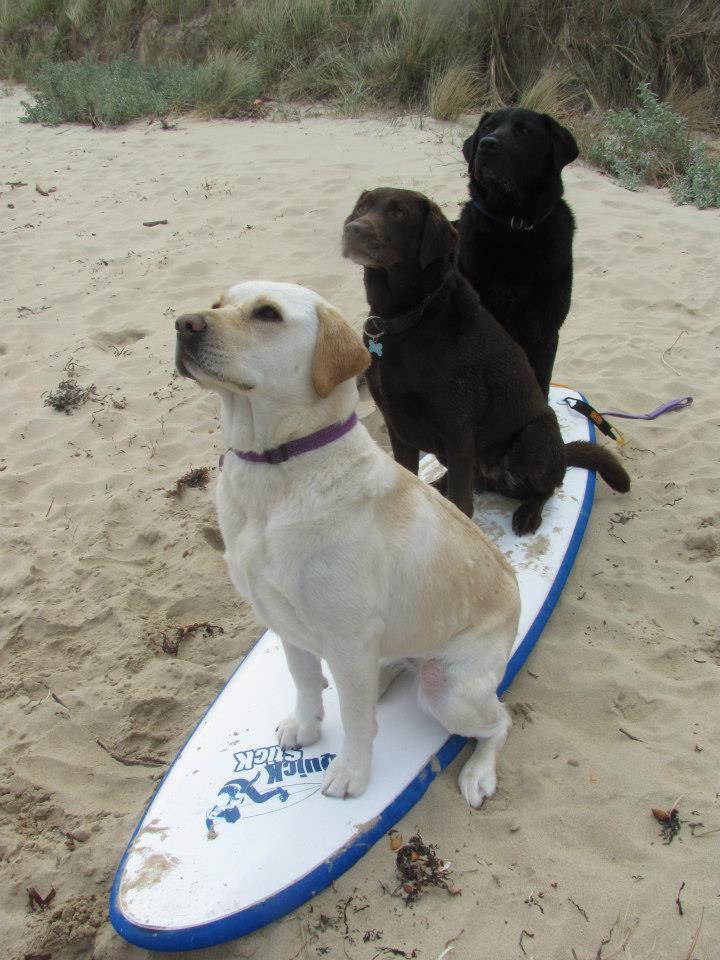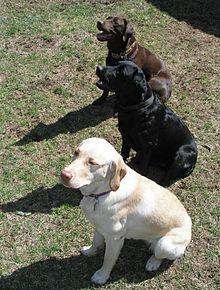The first image is the image on the left, the second image is the image on the right. For the images shown, is this caption "There is only one dog that is definitely in a sitting position." true? Answer yes or no. No. 